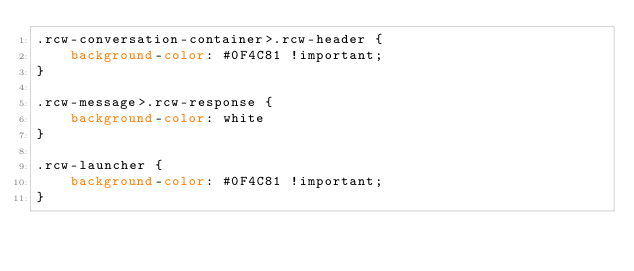<code> <loc_0><loc_0><loc_500><loc_500><_CSS_>.rcw-conversation-container>.rcw-header {
    background-color: #0F4C81 !important;
}

.rcw-message>.rcw-response {
    background-color: white
}

.rcw-launcher {
    background-color: #0F4C81 !important;
}</code> 